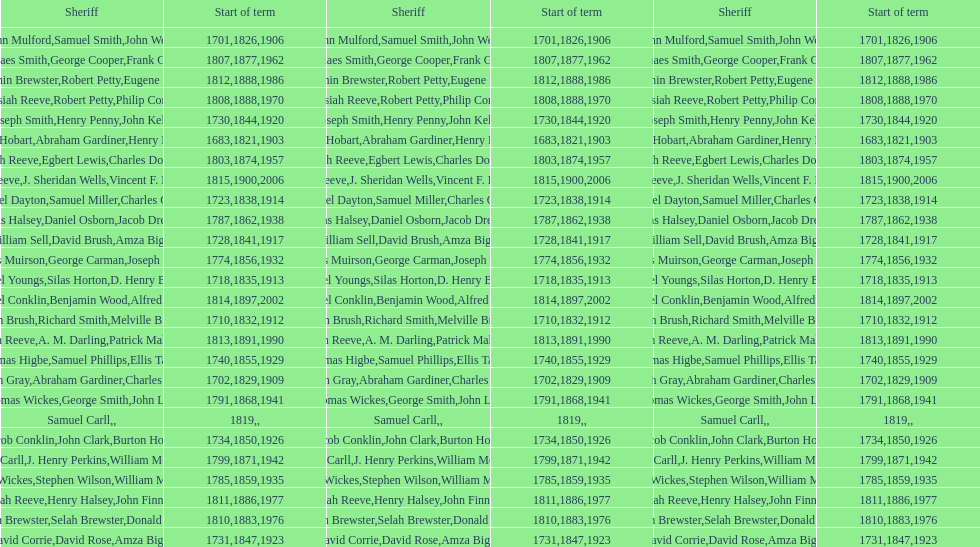Which sheriff came before thomas wickes? James Muirson. 